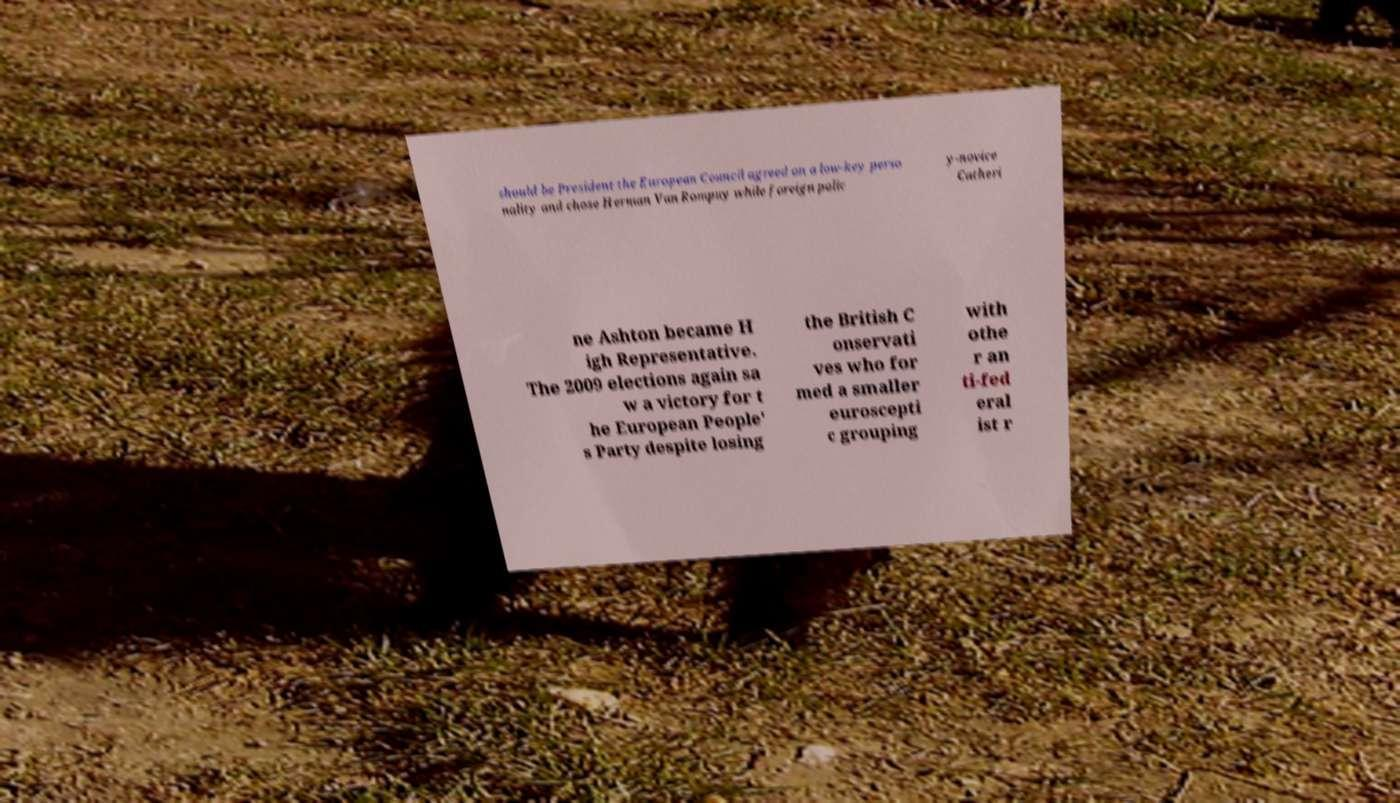For documentation purposes, I need the text within this image transcribed. Could you provide that? should be President the European Council agreed on a low-key perso nality and chose Herman Van Rompuy while foreign polic y-novice Catheri ne Ashton became H igh Representative. The 2009 elections again sa w a victory for t he European People' s Party despite losing the British C onservati ves who for med a smaller euroscepti c grouping with othe r an ti-fed eral ist r 